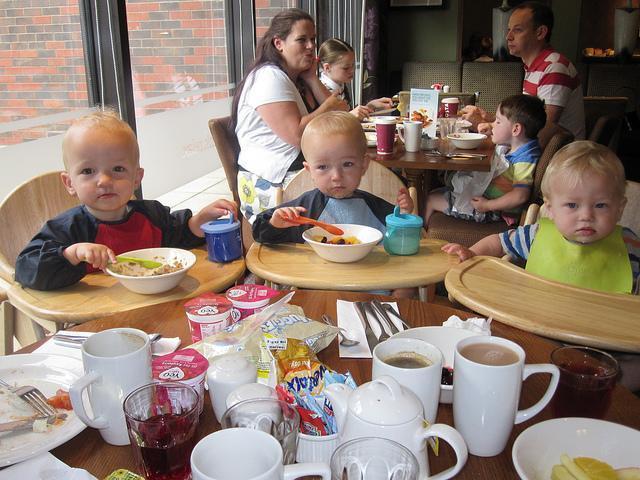Where are these 3 kids most likely from?
Pick the right solution, then justify: 'Answer: answer
Rationale: rationale.'
Options: Same mother, different countries, nigeria, china. Answer: same mother.
Rationale: The kids look alike. 